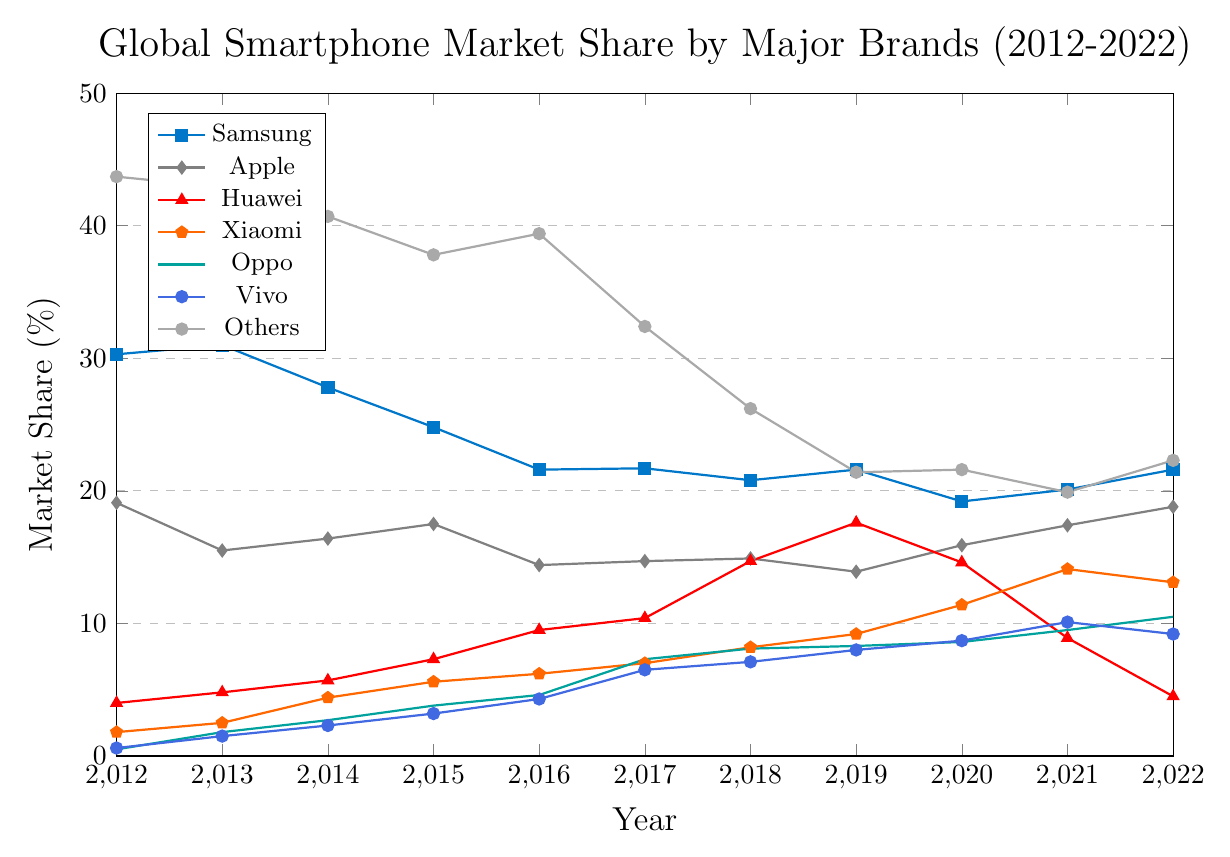What is the overall trend of Samsung's market share from 2012 to 2022? Looking at the line representing Samsung in the chart, the market share starts at around 30% in 2012, declines significantly until 2016 when it bottoms out at about 21%, fluctuates slightly around this value until 2022 where it ends near 21.6%. This indicates a general downward trend with some stability in the later years.
Answer: Downward trend with some stability Comparing Apple and Huawei in 2019, which company had a higher market share and by how much? In 2019, looking at the values for Apple and Huawei, Apple had a market share of 13.9% and Huawei had 17.6%. Subtracting 13.9 from 17.6 gives the difference.
Answer: Huawei by 3.7% What was the market share of "Others" in 2018 and how does it compare to the combined market share of Oppo and Vivo in the same year? Referring to the line for the "Others" category in 2018, it stands at 26.2%. Oppo and Vivo's shares in 2018 are 8.1% and 7.1% respectively, summing these values gives 15.2%. Comparing both, 26.2% for "Others" is significantly higher than 15.2%.
Answer: "Others" had 11% more Which company showed the most significant increase in market share between 2013 and 2018? Observing the lines between 2013 and 2018, Huawei's line shows a significant increase from 4.8% to 14.7%, which is an increase of 9.9 percentage points, more than any other company in the same period.
Answer: Huawei In which year did Vivo's market share first exceed 5%? Looking at the trend for Vivo, the market share crossed the 5% mark between 2015 and 2016, with a value of 6.5% in 2017. Thus, 2017 is the year it first exceeded 5%.
Answer: 2017 What is the average market share of Huawei from 2015 to 2020? Huawei market shares from 2015 to 2020 are 7.3%, 9.5%, 10.4%, 14.7%, 17.6%, and 14.6%. Summing these values gives 74.1%, and dividing by 6 years gives the average market share.
Answer: 12.35% Identify the year in which Xiaomi's market share saw the highest annual growth. Comparing Xiaomi's yearly market shares, the most significant annual growth is from 2020 to 2021, where the share rises from 11.4% to 14.1%, an increase of 2.7 percentage points.
Answer: 2021 How does the market share of the "Others" category in 2022 compare to its market share in 2012? The line for "Others" shows a decrease from 43.7% in 2012 to 22.3% in 2022. The difference can be calculated by subtracting 22.3% from 43.7%.
Answer: It decreased by 21.4% What was the percentage point difference between Samsung and Apple in 2020? Samsung had a market share of 19.2% while Apple had 15.9% in 2020. Subtracting 15.9 from 19.2 gives the difference.
Answer: 3.3 percentage points When did Oppo first reach a market share higher than 5%? Reviewing Oppo's trend, the market share first exceeds 5% in 2016, with a value of 4.6% in 2015 and 7.3% in 2017. This indicates 2017 as the first year it crossed 5%.
Answer: 2017 